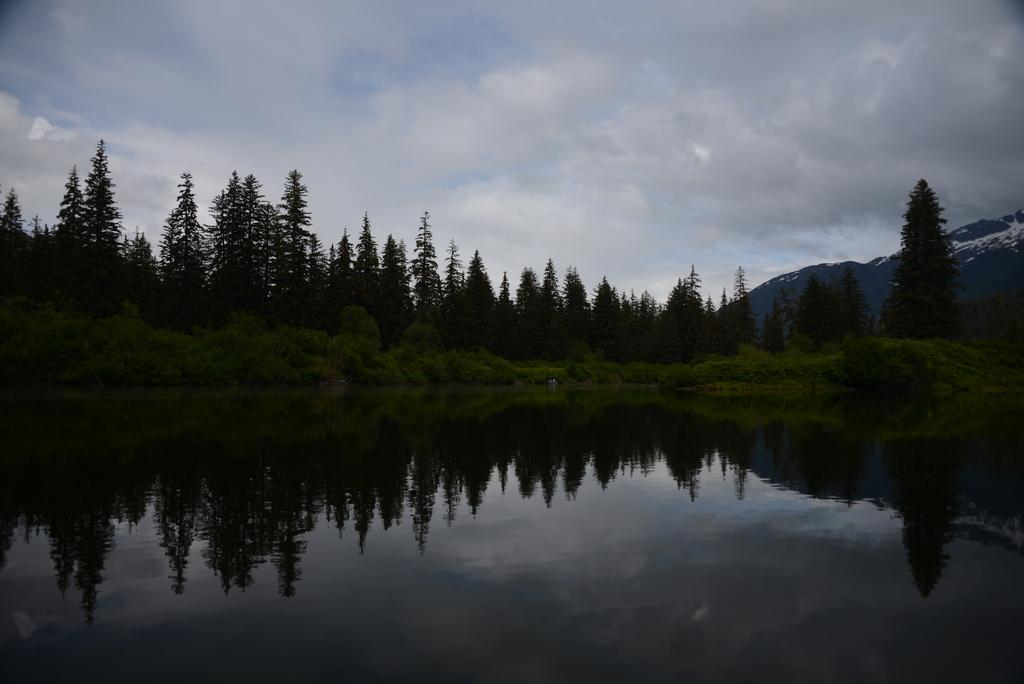What is visible in the image? Water is visible in the image. What can be seen in the background of the image? There are trees, hills, and clouds in the sky in the background of the image. What type of sock is hanging on the tree in the image? There is no sock present in the image; it only features water, trees, hills, and clouds in the sky. 